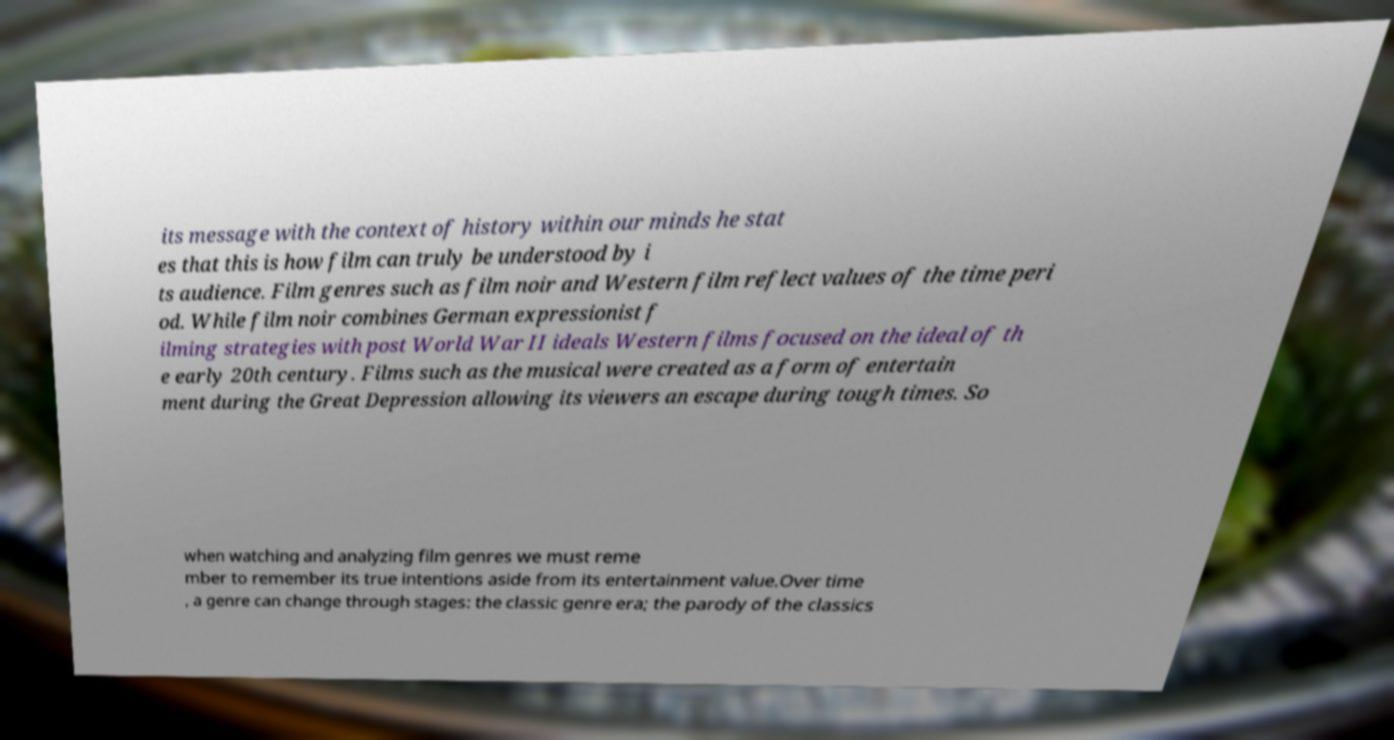Please read and relay the text visible in this image. What does it say? its message with the context of history within our minds he stat es that this is how film can truly be understood by i ts audience. Film genres such as film noir and Western film reflect values of the time peri od. While film noir combines German expressionist f ilming strategies with post World War II ideals Western films focused on the ideal of th e early 20th century. Films such as the musical were created as a form of entertain ment during the Great Depression allowing its viewers an escape during tough times. So when watching and analyzing film genres we must reme mber to remember its true intentions aside from its entertainment value.Over time , a genre can change through stages: the classic genre era; the parody of the classics 